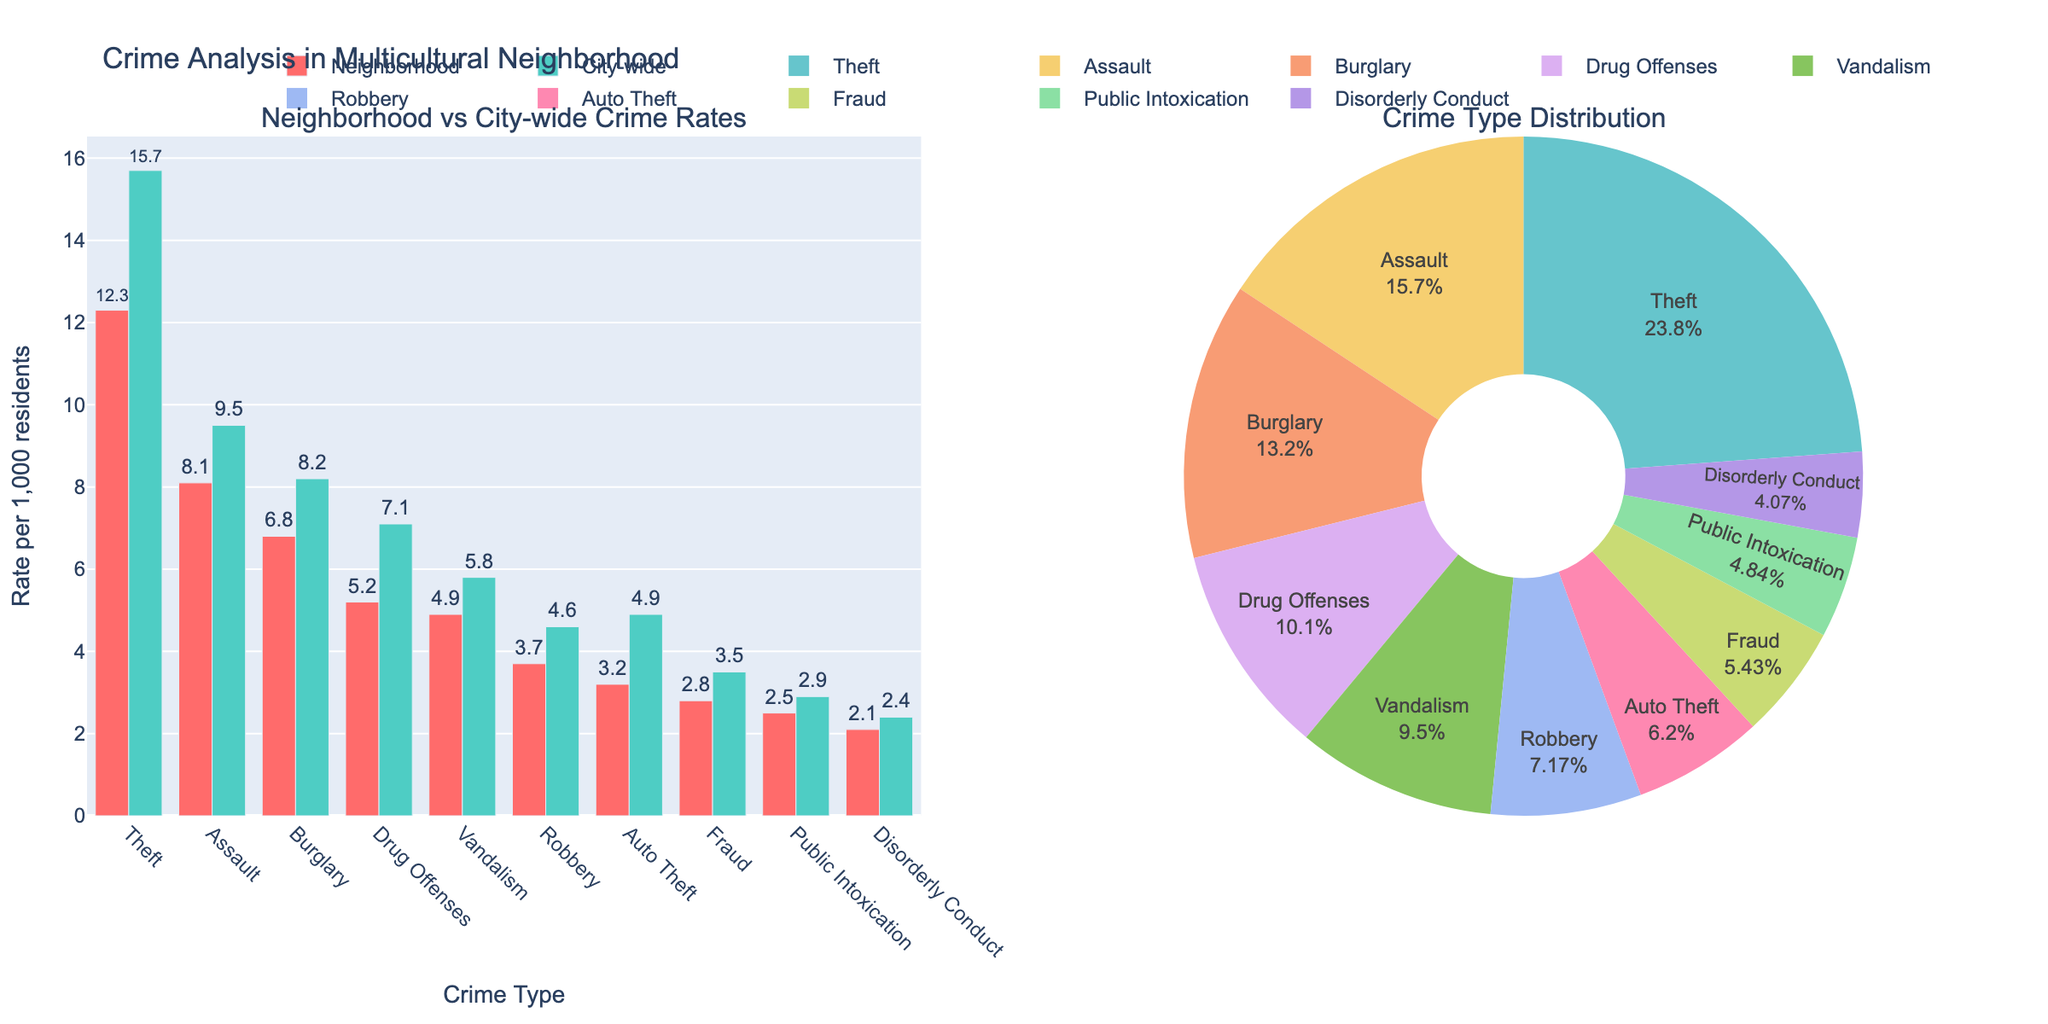How many different crime types are represented in the figure? Count the unique labels on both the bar chart's x-axis and the pie chart's segments. There are 10 crime types represented: Theft, Assault, Burglary, Drug Offenses, Vandalism, Robbery, Auto Theft, Fraud, Public Intoxication, and Disorderly Conduct.
Answer: 10 What is the title of the figure? Read the text at the top of the plot. The title is "Crime Analysis in Multicultural Neighborhood".
Answer: Crime Analysis in Multicultural Neighborhood Which crime type has the highest rate in the neighborhood? Check the heights of bars in the neighborhood bar chart and the largest segment in the pie chart. The tallest bar and largest pie segment represent Theft, which has a rate of 12.3.
Answer: Theft How much higher is the city-wide rate of Theft compared to the neighborhood rate? Subtract the neighborhood rate of Theft (12.3) from the city-wide rate (15.7): 15.7 - 12.3. The result is 3.4.
Answer: 3.4 Among the listed crime types, which one has the smallest difference between neighborhood and city-wide rates? Calculate the differences for each crime type, subtracting the neighborhood rate from the city-wide rate: Theft (3.4), Assault (1.4), Burglary (1.4), Drug Offenses (1.9), Vandalism (0.9), Robbery (0.9), Auto Theft (1.7), Fraud (0.7), Public Intoxication (0.4), Disorderly Conduct (0.3). The smallest difference is for Disorderly Conduct.
Answer: Disorderly Conduct What is the total crime rate for Vandalism in the neighborhood and city-wide combined? Add the neighborhood rate for Vandalism (4.9) to the city-wide rate (5.8): 4.9 + 5.8. The total is 10.7.
Answer: 10.7 In the neighborhood, which crime type has the closest rate to Robbery? Find the neighborhood rate for Robbery (3.7) and compare it to other neighborhood rates: Auto Theft (3.2), Drug Offenses (5.2), Vandalism (4.9), Fraud (2.8), Public Intoxication (2.5), Disorderly Conduct (2.1). Auto Theft, at 3.2, is the closest.
Answer: Auto Theft What percentage of the total neighborhood crime rate is accounted for by Assault? Calculate the total neighborhood crime rate by summing all types: 12.3 (Theft) + 8.1 (Assault) + 6.8 (Burglary) + 5.2 (Drug Offenses) + 4.9 (Vandalism) + 3.7 (Robbery) + 3.2 (Auto Theft) + 2.8 (Fraud) + 2.5 (Public Intoxication) + 2.1 (Disorderly Conduct) = 51.6. Then, divide the rate for Assault by this total and multiply by 100: (8.1 / 51.6) * 100. This results in 15.7%.
Answer: 15.7% Which has a greater difference between neighborhood and city-wide rate: Burglary or Drug Offenses? Compute the differences: for Burglary, city-wide rate (8.2) - neighborhood rate (6.8) = 1.4; for Drug Offenses, city-wide rate (7.1) - neighborhood rate (5.2) = 1.9. The greater difference is for Drug Offenses.
Answer: Drug Offenses 